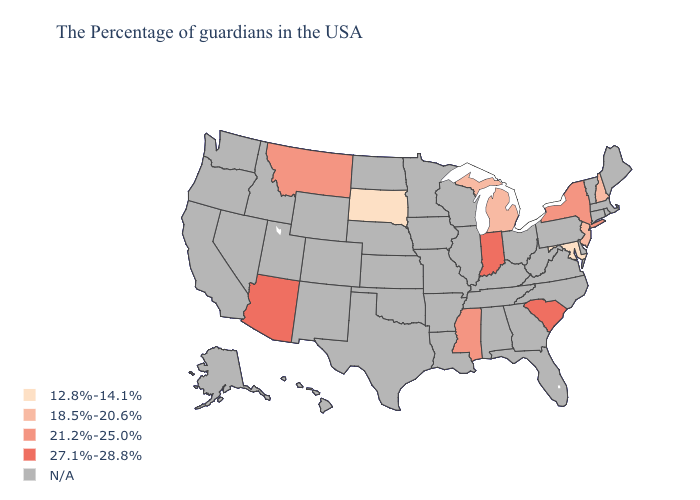What is the highest value in states that border Tennessee?
Quick response, please. 21.2%-25.0%. Name the states that have a value in the range 27.1%-28.8%?
Keep it brief. South Carolina, Indiana, Arizona. Name the states that have a value in the range 21.2%-25.0%?
Keep it brief. New York, Mississippi, Montana. How many symbols are there in the legend?
Write a very short answer. 5. What is the value of Louisiana?
Answer briefly. N/A. Which states hav the highest value in the West?
Quick response, please. Arizona. Does the first symbol in the legend represent the smallest category?
Short answer required. Yes. Among the states that border Tennessee , which have the highest value?
Answer briefly. Mississippi. Which states have the highest value in the USA?
Answer briefly. South Carolina, Indiana, Arizona. Is the legend a continuous bar?
Keep it brief. No. Name the states that have a value in the range 12.8%-14.1%?
Write a very short answer. Maryland, South Dakota. Does the map have missing data?
Short answer required. Yes. What is the value of West Virginia?
Answer briefly. N/A. Which states have the highest value in the USA?
Quick response, please. South Carolina, Indiana, Arizona. 